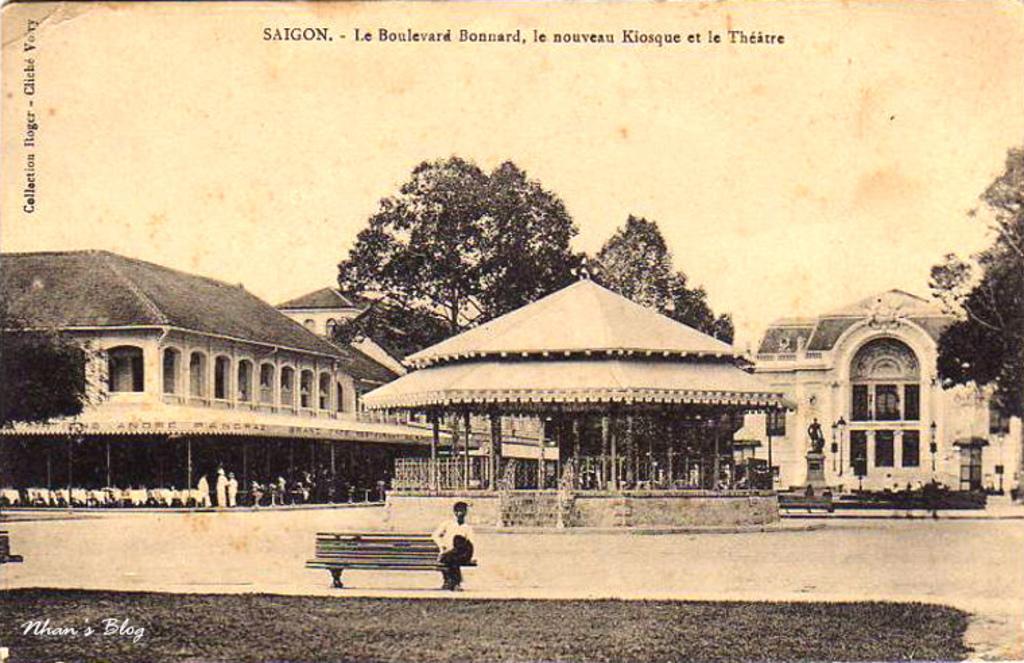Can you describe this image briefly? In this image, we can see photo of a picture. There are buildings and trees in the middle of the image. There is a person at the bottom of the image sitting on the bench in front of the shelter. There is a sky and some text at the top of the image. 